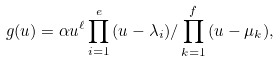<formula> <loc_0><loc_0><loc_500><loc_500>g ( u ) = \alpha u ^ { \ell } \prod _ { i = 1 } ^ { e } { ( u - \lambda _ { i } ) } / \prod _ { k = 1 } ^ { f } { ( u - \mu _ { k } ) } ,</formula> 